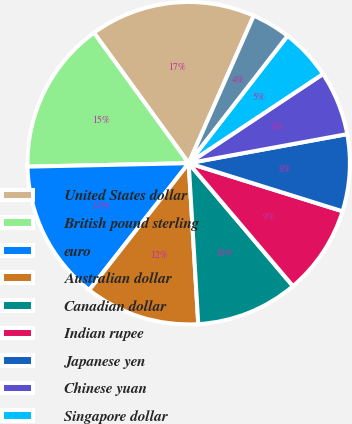Convert chart. <chart><loc_0><loc_0><loc_500><loc_500><pie_chart><fcel>United States dollar<fcel>British pound sterling<fcel>euro<fcel>Australian dollar<fcel>Canadian dollar<fcel>Indian rupee<fcel>Japanese yen<fcel>Chinese yuan<fcel>Singapore dollar<fcel>Hong Kong dollar<nl><fcel>16.61%<fcel>15.34%<fcel>14.07%<fcel>11.53%<fcel>10.25%<fcel>8.98%<fcel>7.71%<fcel>6.44%<fcel>5.17%<fcel>3.89%<nl></chart> 